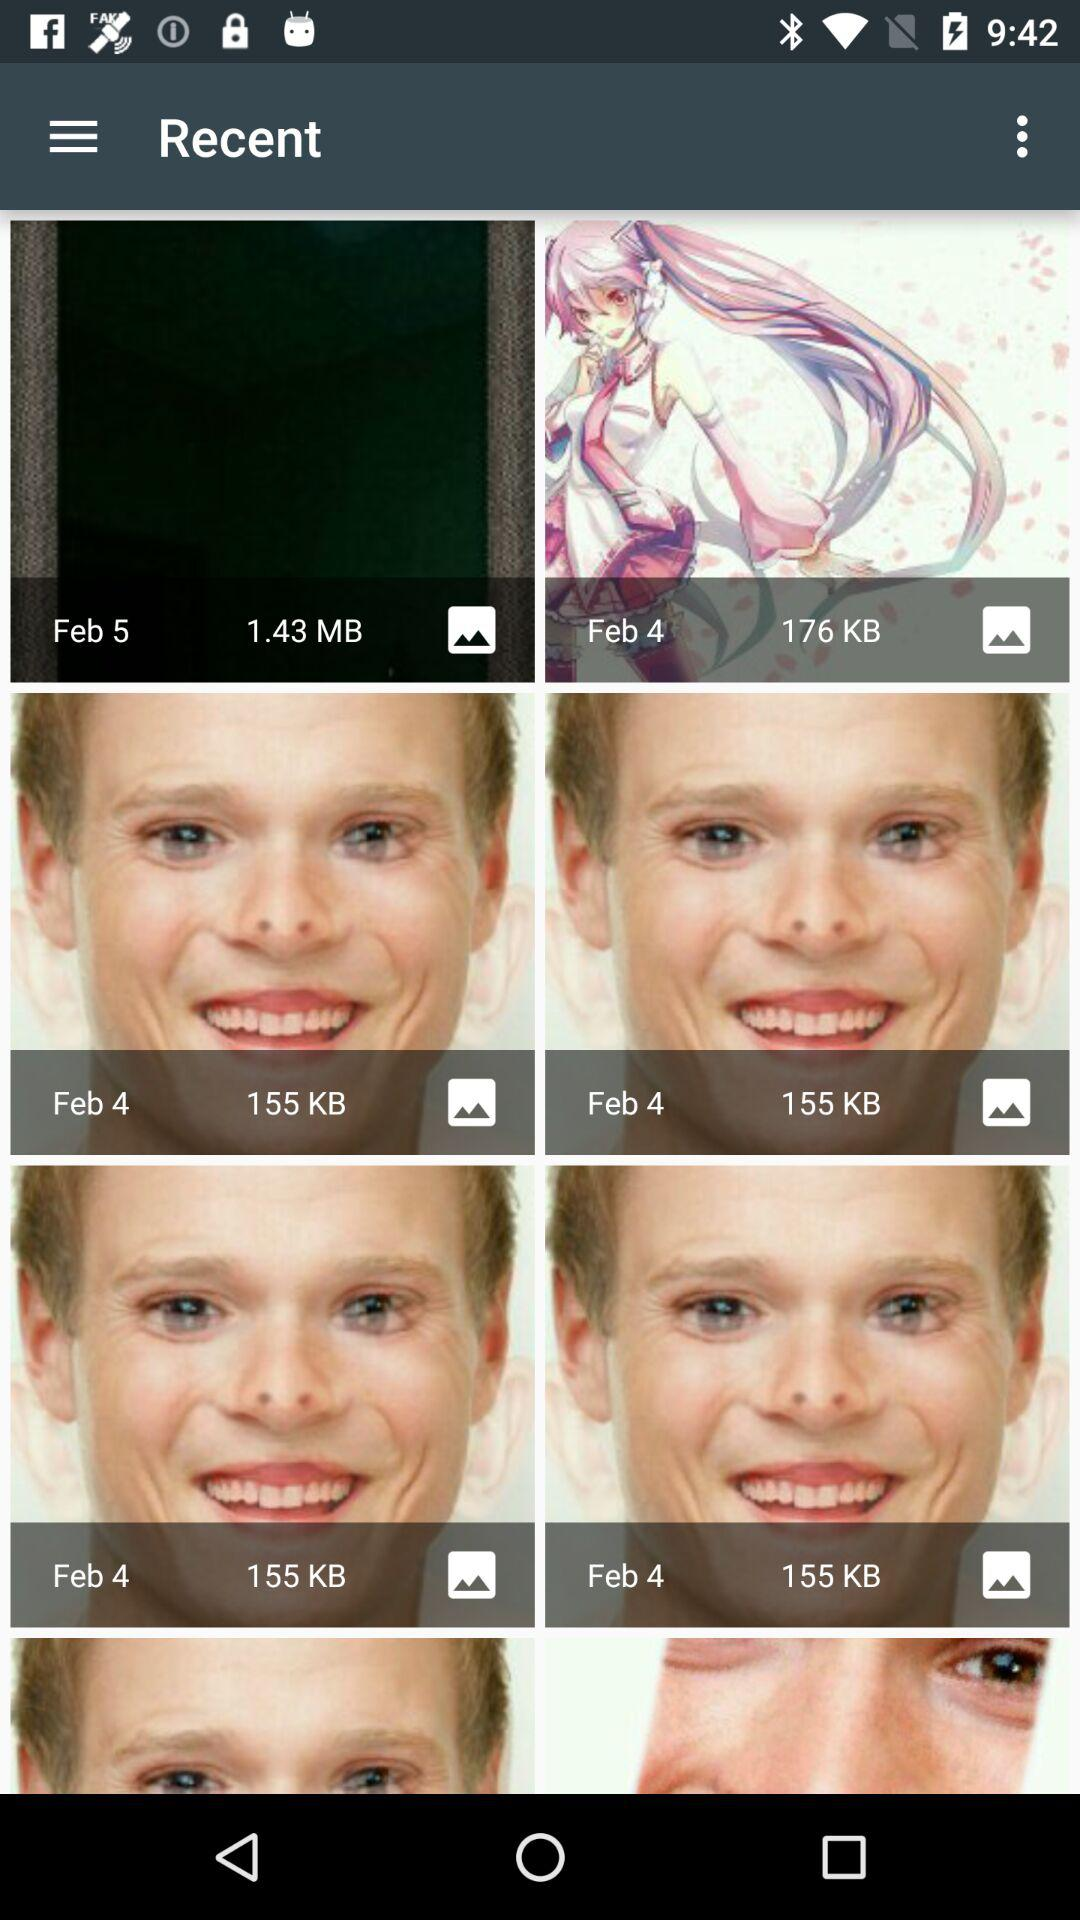What is the size of the photo uploaded on February 5? The size of the photo uploaded on February 5 is 1.43 MB. 